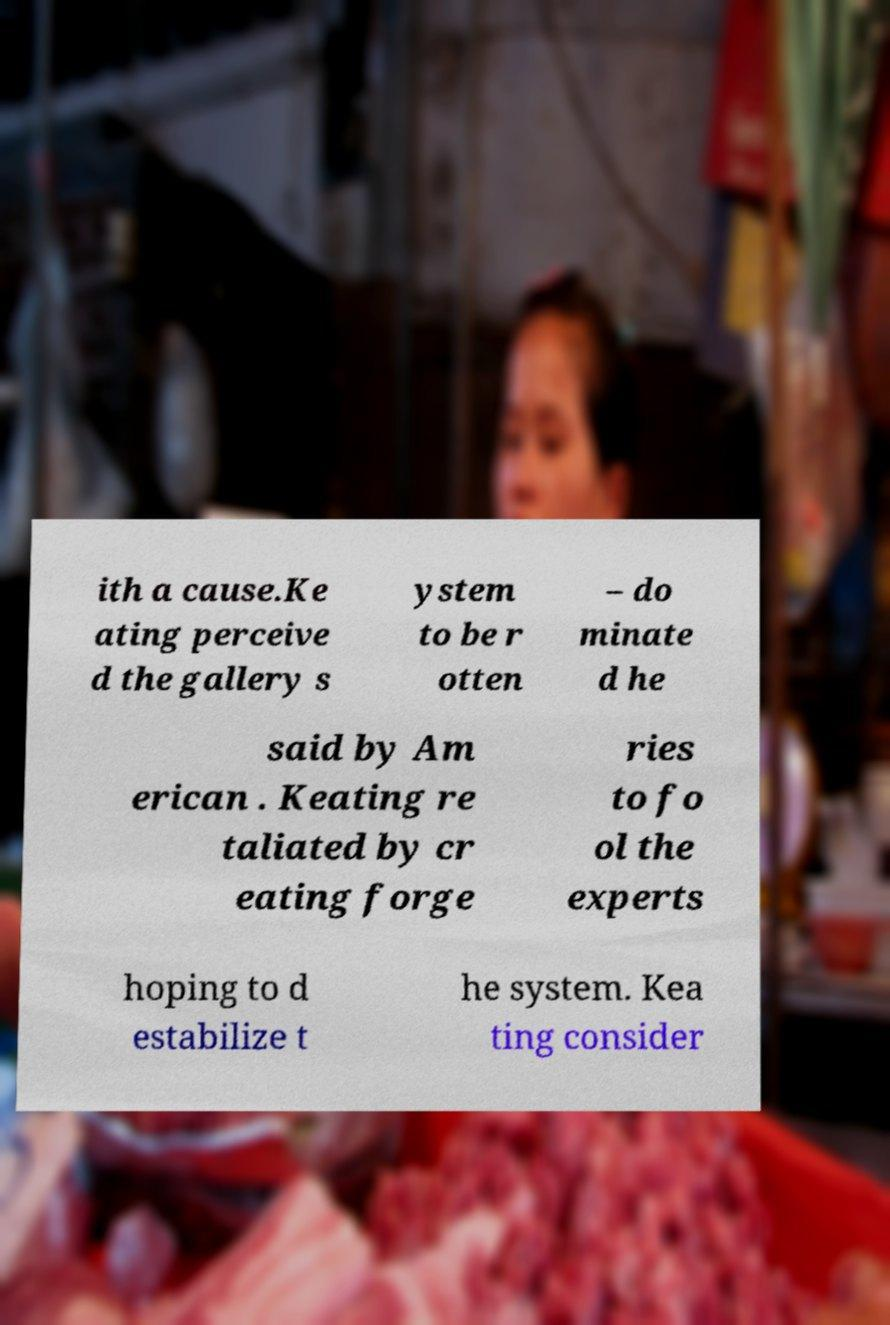Can you accurately transcribe the text from the provided image for me? ith a cause.Ke ating perceive d the gallery s ystem to be r otten – do minate d he said by Am erican . Keating re taliated by cr eating forge ries to fo ol the experts hoping to d estabilize t he system. Kea ting consider 